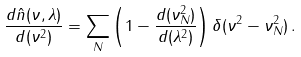Convert formula to latex. <formula><loc_0><loc_0><loc_500><loc_500>\frac { d \hat { n } ( \nu , \lambda ) } { d ( \nu ^ { 2 } ) } = \sum _ { N } \left ( 1 - \frac { d ( \nu _ { N } ^ { 2 } ) } { d ( \lambda ^ { 2 } ) } \right ) \delta ( \nu ^ { 2 } - \nu _ { N } ^ { 2 } ) \, .</formula> 